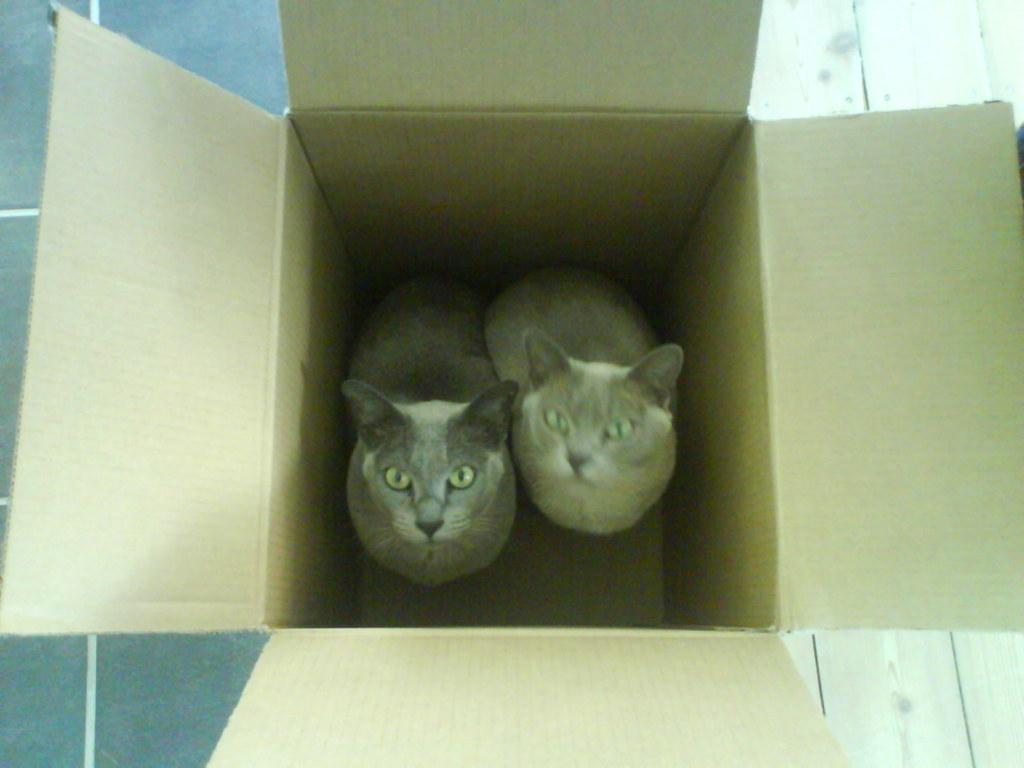What is the main structure in the center of the image? There is a platform in the center of the image. What is placed on the platform? There is a box on the platform. What animals are inside the box? There are two cats in the box. What type of glue is being used by the cats in the box? There is no glue present in the image, and the cats are not using any glue. 